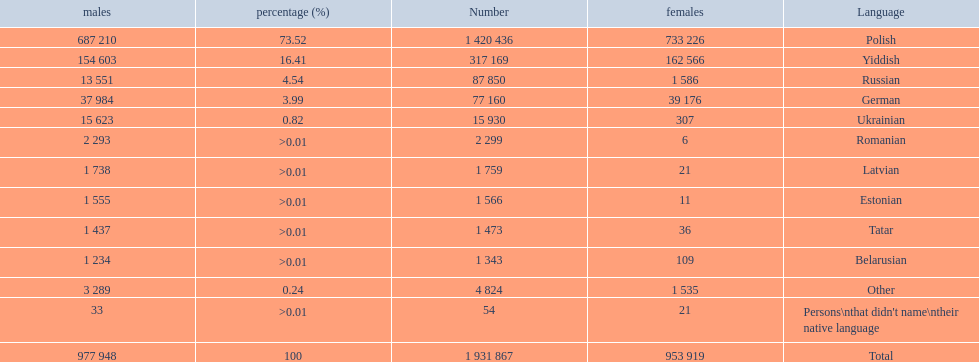What is the percentage of polish speakers? 73.52. What is the next highest percentage of speakers? 16.41. Could you help me parse every detail presented in this table? {'header': ['males', 'percentage (%)', 'Number', 'females', 'Language'], 'rows': [['687 210', '73.52', '1 420 436', '733 226', 'Polish'], ['154 603', '16.41', '317 169', '162 566', 'Yiddish'], ['13 551', '4.54', '87 850', '1 586', 'Russian'], ['37 984', '3.99', '77 160', '39 176', 'German'], ['15 623', '0.82', '15 930', '307', 'Ukrainian'], ['2 293', '>0.01', '2 299', '6', 'Romanian'], ['1 738', '>0.01', '1 759', '21', 'Latvian'], ['1 555', '>0.01', '1 566', '11', 'Estonian'], ['1 437', '>0.01', '1 473', '36', 'Tatar'], ['1 234', '>0.01', '1 343', '109', 'Belarusian'], ['3 289', '0.24', '4 824', '1 535', 'Other'], ['33', '>0.01', '54', '21', "Persons\\nthat didn't name\\ntheir native language"], ['977 948', '100', '1 931 867', '953 919', 'Total']]} What language is this percentage? Yiddish. 